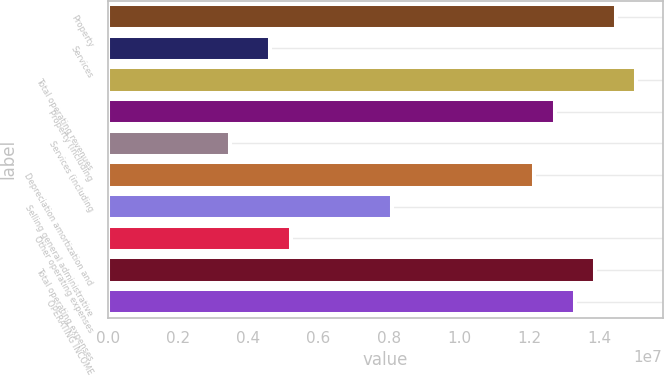Convert chart. <chart><loc_0><loc_0><loc_500><loc_500><bar_chart><fcel>Property<fcel>Services<fcel>Total operating revenues<fcel>Property (including<fcel>Services (including<fcel>Depreciation amortization and<fcel>Selling general administrative<fcel>Other operating expenses<fcel>Total operating expenses<fcel>OPERATING INCOME<nl><fcel>1.44642e+07<fcel>4.62853e+06<fcel>1.50427e+07<fcel>1.27285e+07<fcel>3.4714e+06<fcel>1.21499e+07<fcel>8.09993e+06<fcel>5.2071e+06<fcel>1.38856e+07<fcel>1.3307e+07<nl></chart> 